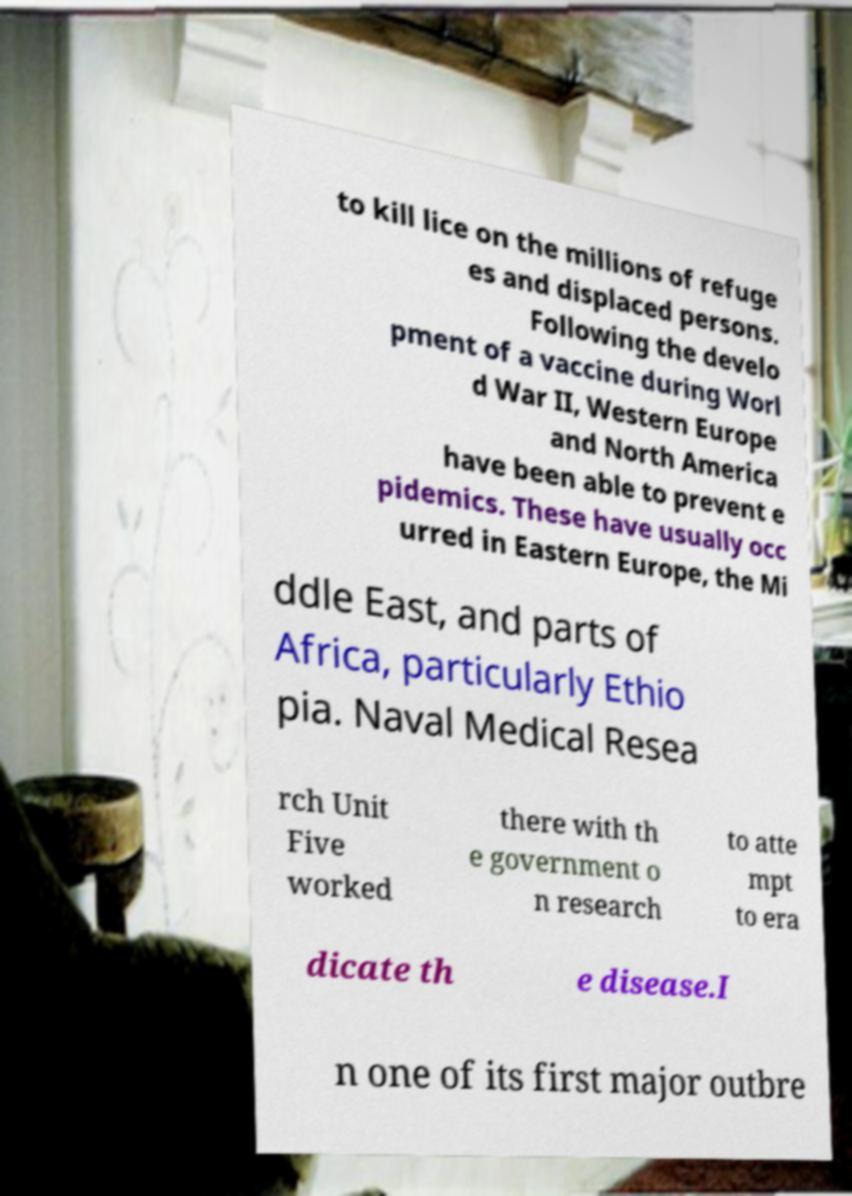Can you read and provide the text displayed in the image?This photo seems to have some interesting text. Can you extract and type it out for me? to kill lice on the millions of refuge es and displaced persons. Following the develo pment of a vaccine during Worl d War II, Western Europe and North America have been able to prevent e pidemics. These have usually occ urred in Eastern Europe, the Mi ddle East, and parts of Africa, particularly Ethio pia. Naval Medical Resea rch Unit Five worked there with th e government o n research to atte mpt to era dicate th e disease.I n one of its first major outbre 